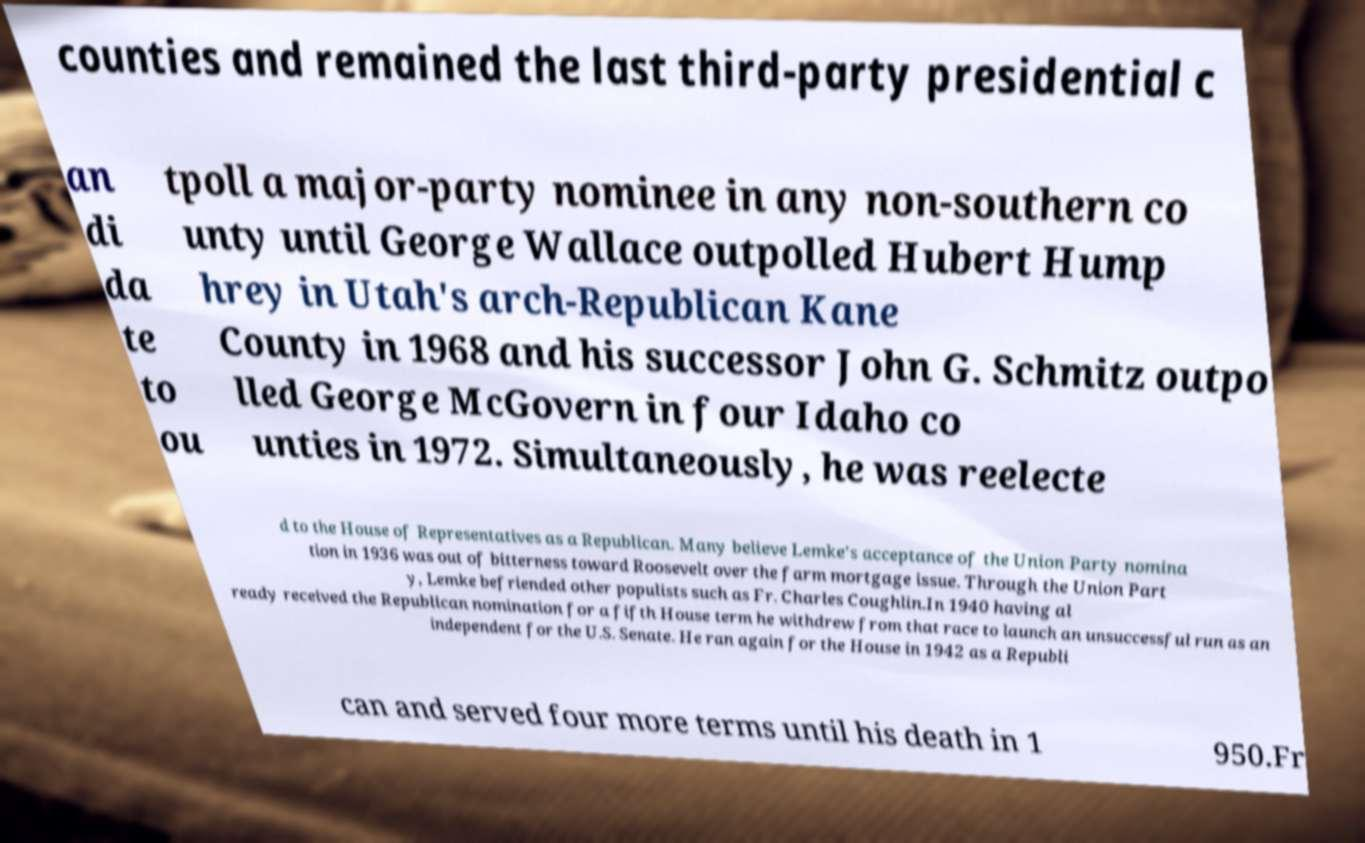For documentation purposes, I need the text within this image transcribed. Could you provide that? counties and remained the last third-party presidential c an di da te to ou tpoll a major-party nominee in any non-southern co unty until George Wallace outpolled Hubert Hump hrey in Utah's arch-Republican Kane County in 1968 and his successor John G. Schmitz outpo lled George McGovern in four Idaho co unties in 1972. Simultaneously, he was reelecte d to the House of Representatives as a Republican. Many believe Lemke's acceptance of the Union Party nomina tion in 1936 was out of bitterness toward Roosevelt over the farm mortgage issue. Through the Union Part y, Lemke befriended other populists such as Fr. Charles Coughlin.In 1940 having al ready received the Republican nomination for a fifth House term he withdrew from that race to launch an unsuccessful run as an independent for the U.S. Senate. He ran again for the House in 1942 as a Republi can and served four more terms until his death in 1 950.Fr 